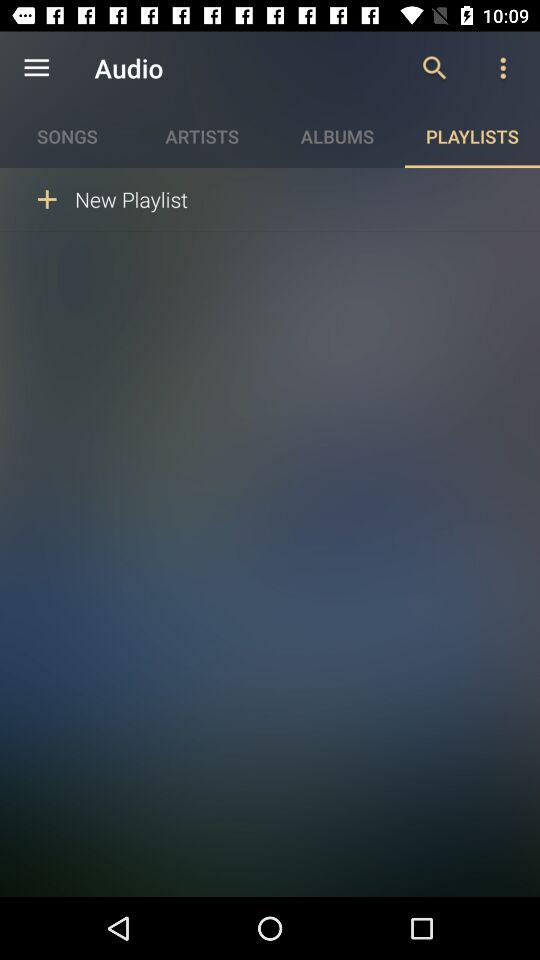Which tab is selected? The selected tab is "PLAYLISTS". 